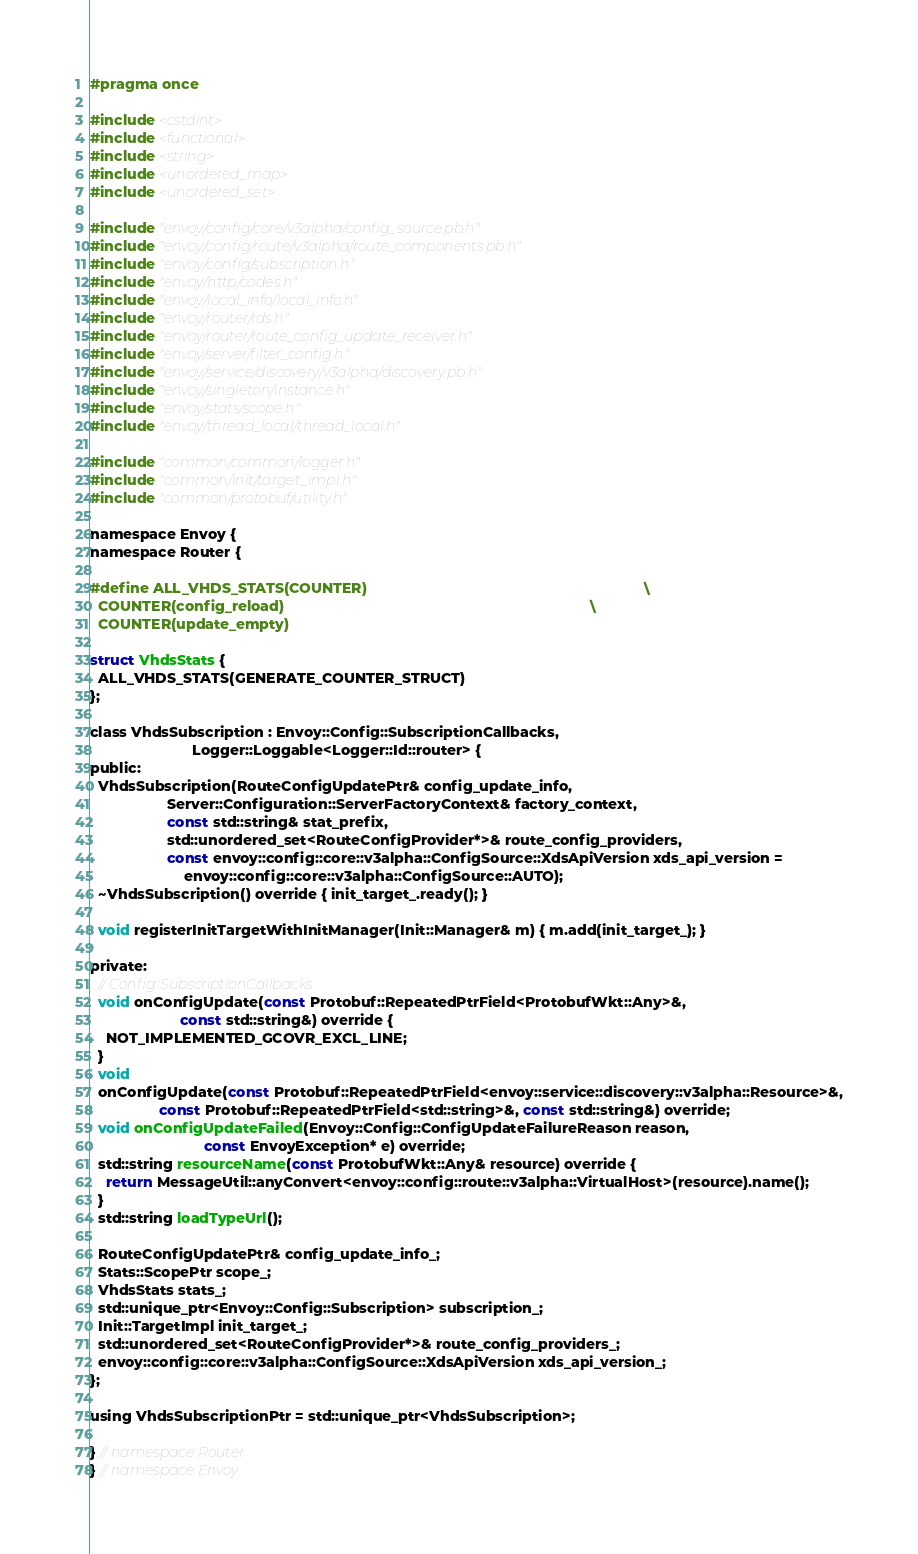<code> <loc_0><loc_0><loc_500><loc_500><_C_>#pragma once

#include <cstdint>
#include <functional>
#include <string>
#include <unordered_map>
#include <unordered_set>

#include "envoy/config/core/v3alpha/config_source.pb.h"
#include "envoy/config/route/v3alpha/route_components.pb.h"
#include "envoy/config/subscription.h"
#include "envoy/http/codes.h"
#include "envoy/local_info/local_info.h"
#include "envoy/router/rds.h"
#include "envoy/router/route_config_update_receiver.h"
#include "envoy/server/filter_config.h"
#include "envoy/service/discovery/v3alpha/discovery.pb.h"
#include "envoy/singleton/instance.h"
#include "envoy/stats/scope.h"
#include "envoy/thread_local/thread_local.h"

#include "common/common/logger.h"
#include "common/init/target_impl.h"
#include "common/protobuf/utility.h"

namespace Envoy {
namespace Router {

#define ALL_VHDS_STATS(COUNTER)                                                                    \
  COUNTER(config_reload)                                                                           \
  COUNTER(update_empty)

struct VhdsStats {
  ALL_VHDS_STATS(GENERATE_COUNTER_STRUCT)
};

class VhdsSubscription : Envoy::Config::SubscriptionCallbacks,
                         Logger::Loggable<Logger::Id::router> {
public:
  VhdsSubscription(RouteConfigUpdatePtr& config_update_info,
                   Server::Configuration::ServerFactoryContext& factory_context,
                   const std::string& stat_prefix,
                   std::unordered_set<RouteConfigProvider*>& route_config_providers,
                   const envoy::config::core::v3alpha::ConfigSource::XdsApiVersion xds_api_version =
                       envoy::config::core::v3alpha::ConfigSource::AUTO);
  ~VhdsSubscription() override { init_target_.ready(); }

  void registerInitTargetWithInitManager(Init::Manager& m) { m.add(init_target_); }

private:
  // Config::SubscriptionCallbacks
  void onConfigUpdate(const Protobuf::RepeatedPtrField<ProtobufWkt::Any>&,
                      const std::string&) override {
    NOT_IMPLEMENTED_GCOVR_EXCL_LINE;
  }
  void
  onConfigUpdate(const Protobuf::RepeatedPtrField<envoy::service::discovery::v3alpha::Resource>&,
                 const Protobuf::RepeatedPtrField<std::string>&, const std::string&) override;
  void onConfigUpdateFailed(Envoy::Config::ConfigUpdateFailureReason reason,
                            const EnvoyException* e) override;
  std::string resourceName(const ProtobufWkt::Any& resource) override {
    return MessageUtil::anyConvert<envoy::config::route::v3alpha::VirtualHost>(resource).name();
  }
  std::string loadTypeUrl();

  RouteConfigUpdatePtr& config_update_info_;
  Stats::ScopePtr scope_;
  VhdsStats stats_;
  std::unique_ptr<Envoy::Config::Subscription> subscription_;
  Init::TargetImpl init_target_;
  std::unordered_set<RouteConfigProvider*>& route_config_providers_;
  envoy::config::core::v3alpha::ConfigSource::XdsApiVersion xds_api_version_;
};

using VhdsSubscriptionPtr = std::unique_ptr<VhdsSubscription>;

} // namespace Router
} // namespace Envoy
</code> 